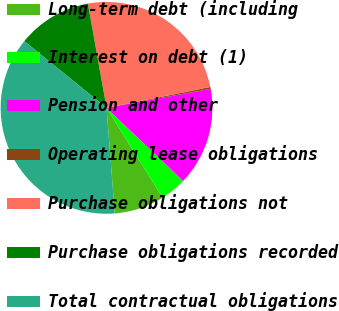<chart> <loc_0><loc_0><loc_500><loc_500><pie_chart><fcel>Long-term debt (including<fcel>Interest on debt (1)<fcel>Pension and other<fcel>Operating lease obligations<fcel>Purchase obligations not<fcel>Purchase obligations recorded<fcel>Total contractual obligations<nl><fcel>7.65%<fcel>3.97%<fcel>15.01%<fcel>0.29%<fcel>24.65%<fcel>11.33%<fcel>37.09%<nl></chart> 